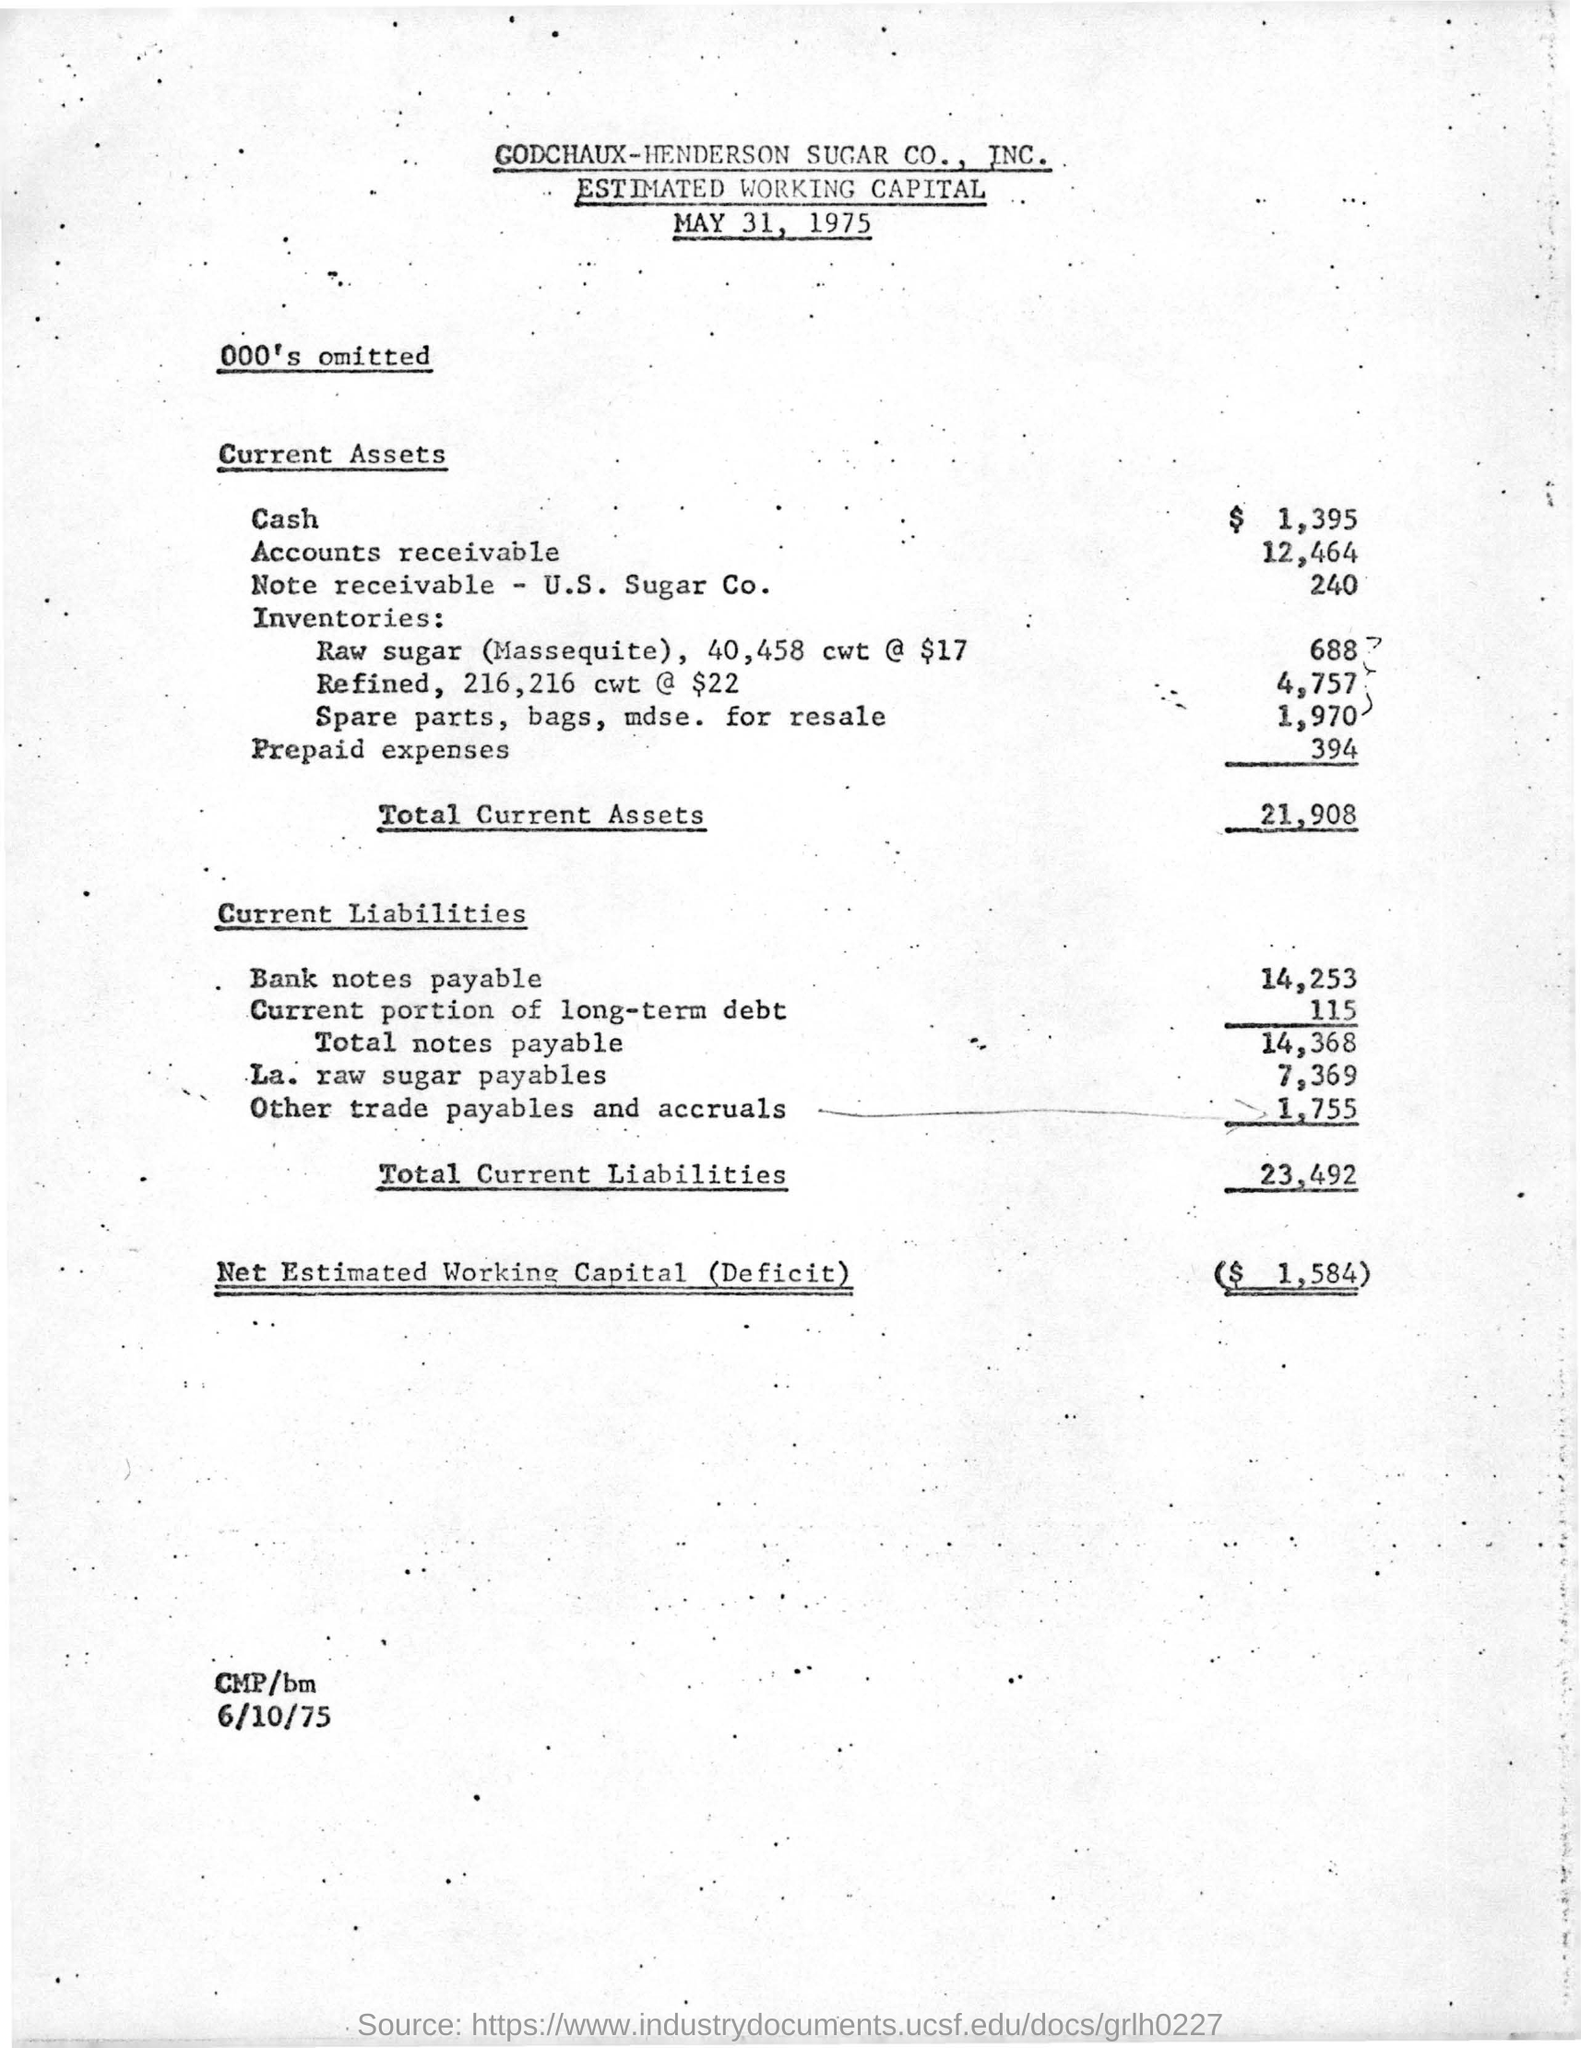List a handful of essential elements in this visual. The total amount of current liabilities is 23,492. The date mentioned at the bottom of the document is 6/10/75. The total amount of current assets is 21,908. The net estimated working capital is $1,584. The document at the top of the page bears the title "GODCHAUX-HENDERSON SUGAR CO., INC." 